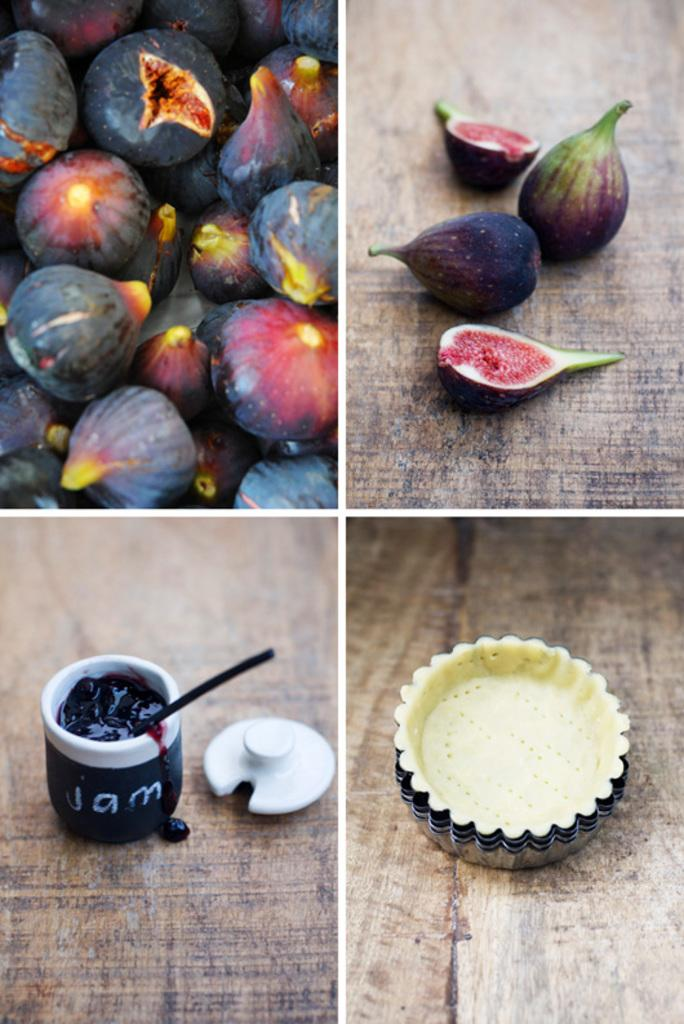What type of artwork is shown in the image? The image is a collage. What can be seen in the first two pictures of the collage? There are fruits in the first two pictures of the collage. What is featured in the third picture of the collage? There is a jar of jam in the third picture of the collage. What is shown in the fourth picture of the collage? There is a collection of molds in the fourth picture of the collage. What does the dad say about the bubble in the image? There is no dad or bubble present in the image. How many men are visible in the image? There are no men visible in the image; it is a collage featuring fruits, jam, and molds. 